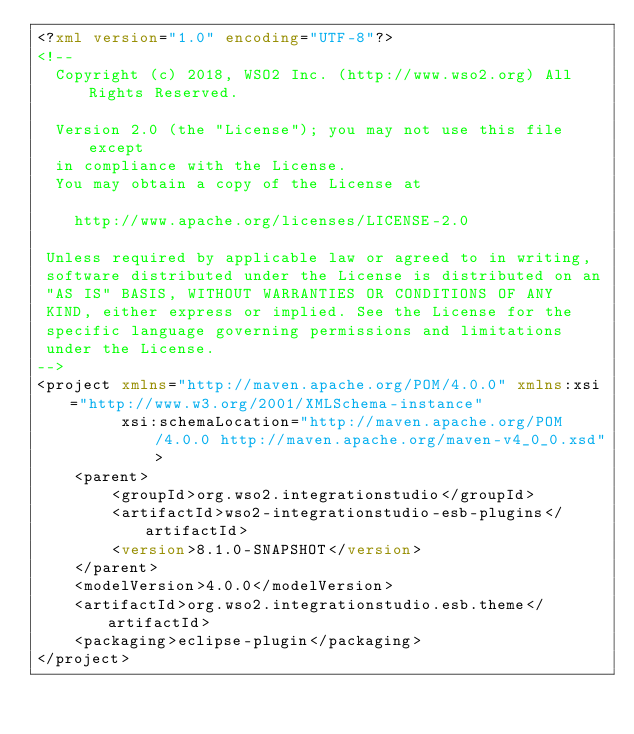Convert code to text. <code><loc_0><loc_0><loc_500><loc_500><_XML_><?xml version="1.0" encoding="UTF-8"?>
<!--
  Copyright (c) 2018, WSO2 Inc. (http://www.wso2.org) All Rights Reserved.

  Version 2.0 (the "License"); you may not use this file except
  in compliance with the License.
  You may obtain a copy of the License at

    http://www.apache.org/licenses/LICENSE-2.0

 Unless required by applicable law or agreed to in writing,
 software distributed under the License is distributed on an
 "AS IS" BASIS, WITHOUT WARRANTIES OR CONDITIONS OF ANY
 KIND, either express or implied. See the License for the
 specific language governing permissions and limitations
 under the License.
-->
<project xmlns="http://maven.apache.org/POM/4.0.0" xmlns:xsi="http://www.w3.org/2001/XMLSchema-instance"
         xsi:schemaLocation="http://maven.apache.org/POM/4.0.0 http://maven.apache.org/maven-v4_0_0.xsd">
    <parent>
        <groupId>org.wso2.integrationstudio</groupId>
        <artifactId>wso2-integrationstudio-esb-plugins</artifactId>
        <version>8.1.0-SNAPSHOT</version>
    </parent>
    <modelVersion>4.0.0</modelVersion>
    <artifactId>org.wso2.integrationstudio.esb.theme</artifactId>
    <packaging>eclipse-plugin</packaging>
</project>
</code> 